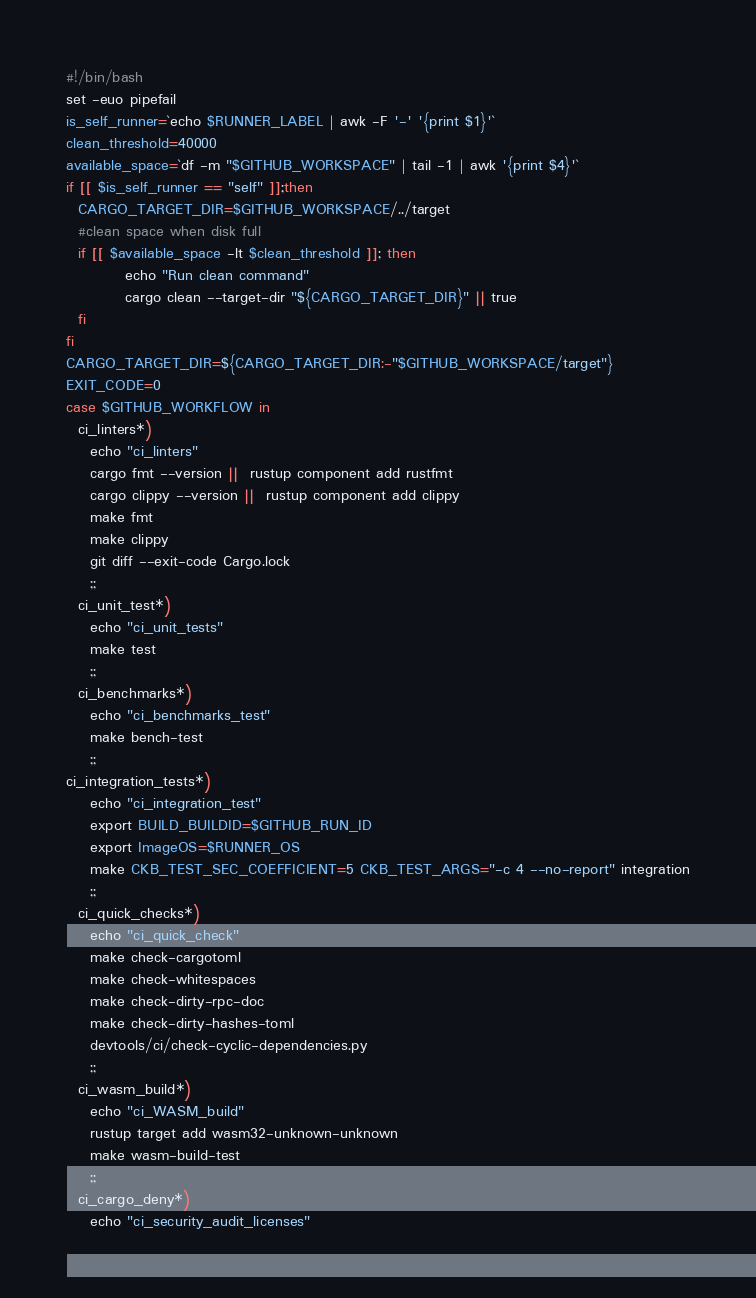Convert code to text. <code><loc_0><loc_0><loc_500><loc_500><_Bash_>#!/bin/bash
set -euo pipefail
is_self_runner=`echo $RUNNER_LABEL | awk -F '-' '{print $1}'`
clean_threshold=40000
available_space=`df -m "$GITHUB_WORKSPACE" | tail -1 | awk '{print $4}'`
if [[ $is_self_runner == "self" ]];then
  CARGO_TARGET_DIR=$GITHUB_WORKSPACE/../target
  #clean space when disk full
  if [[ $available_space -lt $clean_threshold ]]; then
          echo "Run clean command"
          cargo clean --target-dir "${CARGO_TARGET_DIR}" || true
  fi
fi
CARGO_TARGET_DIR=${CARGO_TARGET_DIR:-"$GITHUB_WORKSPACE/target"}
EXIT_CODE=0
case $GITHUB_WORKFLOW in
  ci_linters*)
    echo "ci_linters"
    cargo fmt --version ||  rustup component add rustfmt
    cargo clippy --version ||  rustup component add clippy
    make fmt
    make clippy
    git diff --exit-code Cargo.lock
    ;;
  ci_unit_test*)
    echo "ci_unit_tests"
    make test
    ;;
  ci_benchmarks*)
    echo "ci_benchmarks_test"
    make bench-test
    ;;
ci_integration_tests*)
    echo "ci_integration_test"
    export BUILD_BUILDID=$GITHUB_RUN_ID
    export ImageOS=$RUNNER_OS
    make CKB_TEST_SEC_COEFFICIENT=5 CKB_TEST_ARGS="-c 4 --no-report" integration
    ;;
  ci_quick_checks*)
    echo "ci_quick_check"
    make check-cargotoml
    make check-whitespaces
    make check-dirty-rpc-doc
    make check-dirty-hashes-toml
    devtools/ci/check-cyclic-dependencies.py
    ;;
  ci_wasm_build*)
    echo "ci_WASM_build"
    rustup target add wasm32-unknown-unknown
    make wasm-build-test
    ;;
  ci_cargo_deny*)
    echo "ci_security_audit_licenses"</code> 